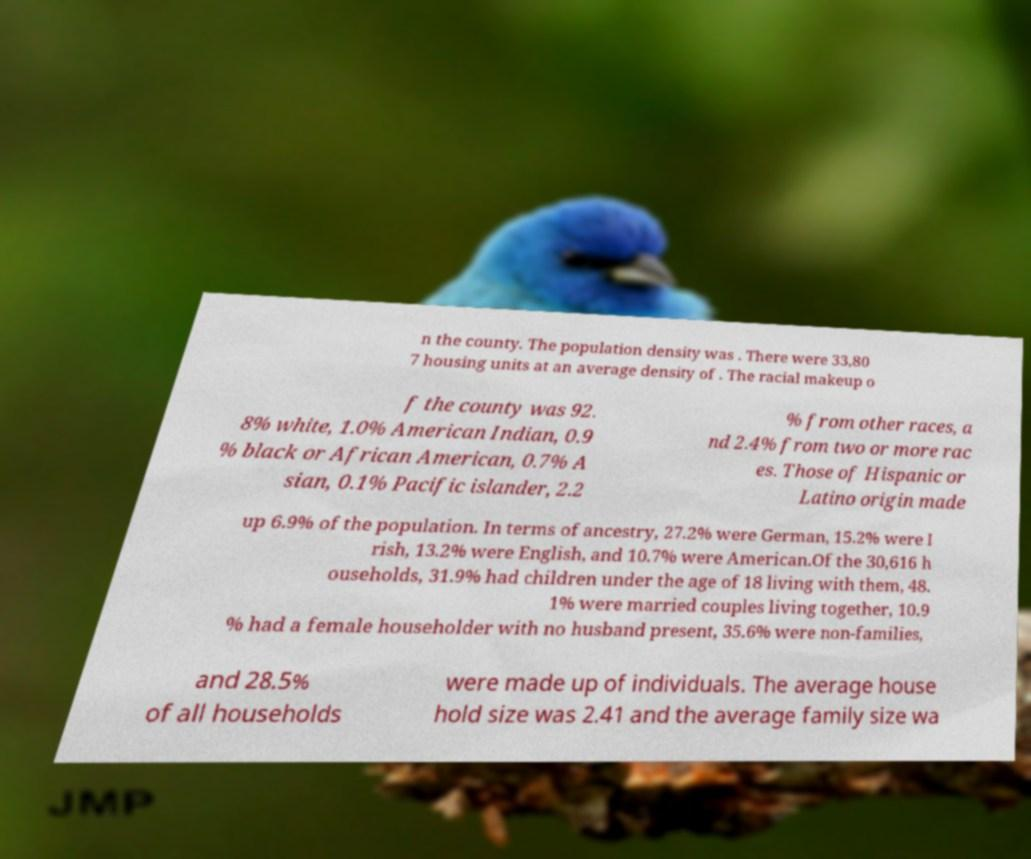For documentation purposes, I need the text within this image transcribed. Could you provide that? n the county. The population density was . There were 33,80 7 housing units at an average density of . The racial makeup o f the county was 92. 8% white, 1.0% American Indian, 0.9 % black or African American, 0.7% A sian, 0.1% Pacific islander, 2.2 % from other races, a nd 2.4% from two or more rac es. Those of Hispanic or Latino origin made up 6.9% of the population. In terms of ancestry, 27.2% were German, 15.2% were I rish, 13.2% were English, and 10.7% were American.Of the 30,616 h ouseholds, 31.9% had children under the age of 18 living with them, 48. 1% were married couples living together, 10.9 % had a female householder with no husband present, 35.6% were non-families, and 28.5% of all households were made up of individuals. The average house hold size was 2.41 and the average family size wa 